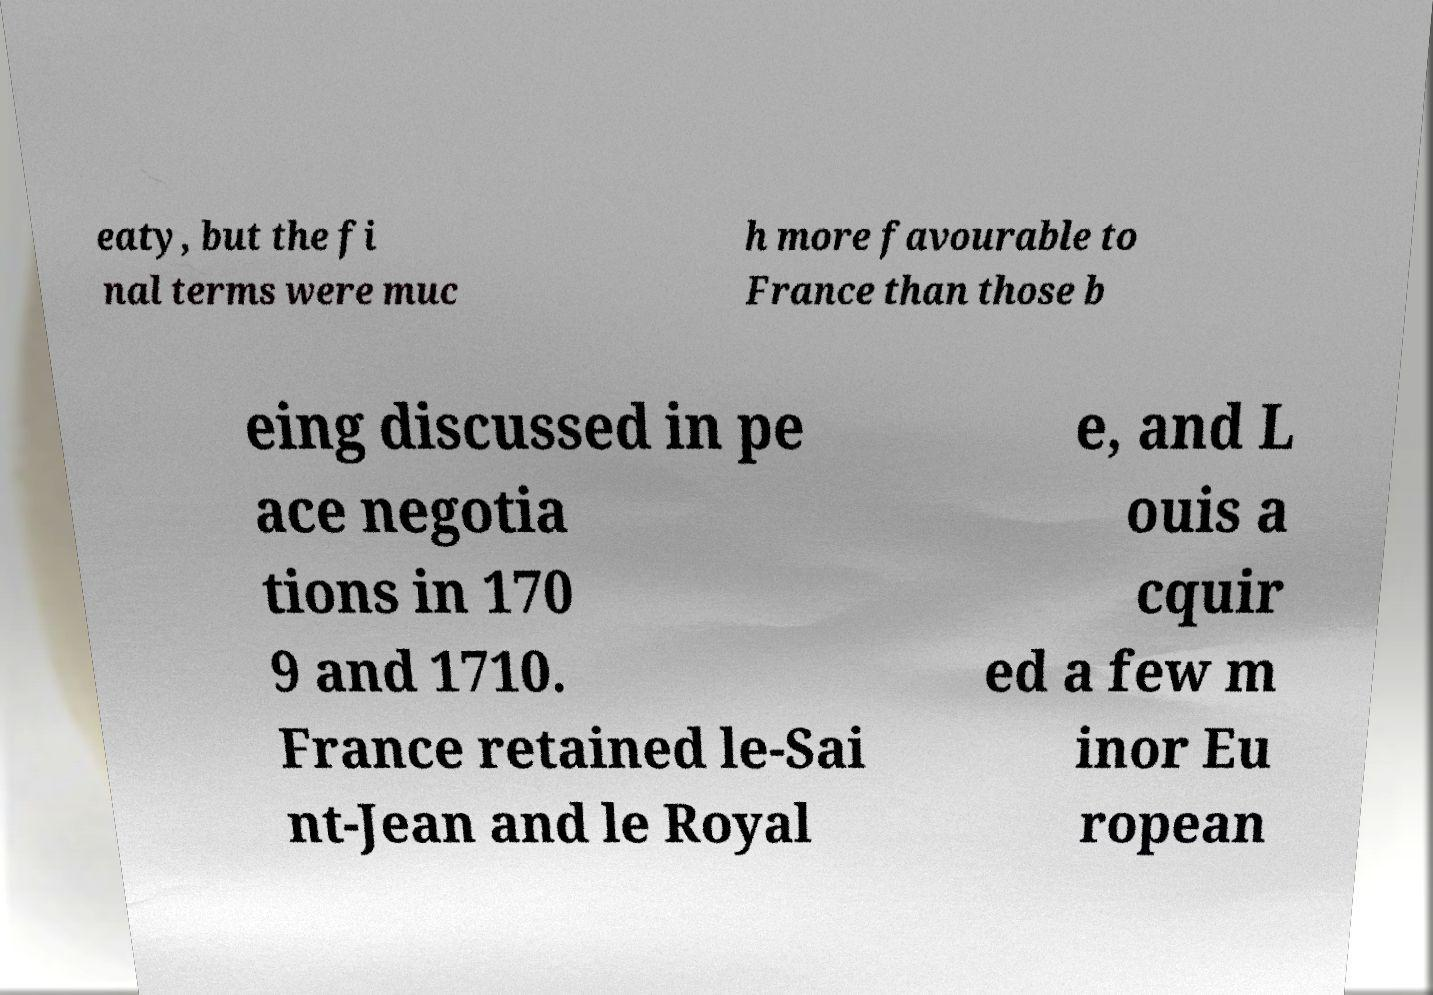There's text embedded in this image that I need extracted. Can you transcribe it verbatim? eaty, but the fi nal terms were muc h more favourable to France than those b eing discussed in pe ace negotia tions in 170 9 and 1710. France retained le-Sai nt-Jean and le Royal e, and L ouis a cquir ed a few m inor Eu ropean 